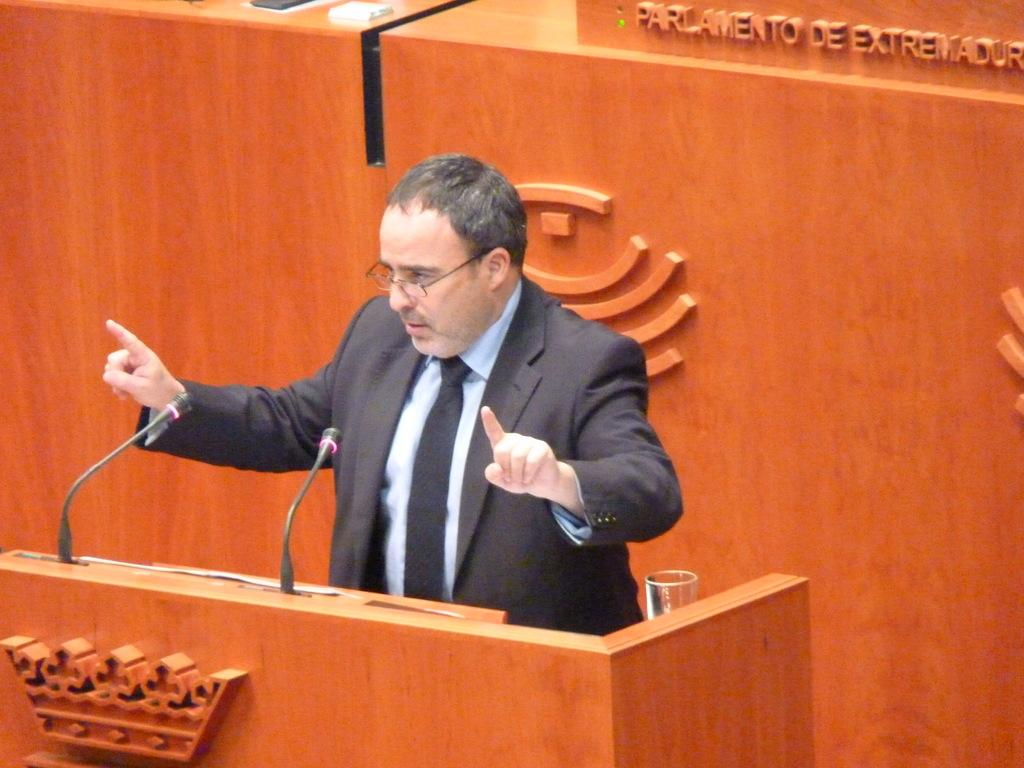Who is the main subject in the image? There is a man in the center of the image. What objects can be seen near the man? There are two microphones in the image. What piece of furniture is present in the image? There is a desk in the image. What type of pollution can be seen in the image? There is no pollution present in the image. Where is the oven located in the image? There is no oven present in the image. 